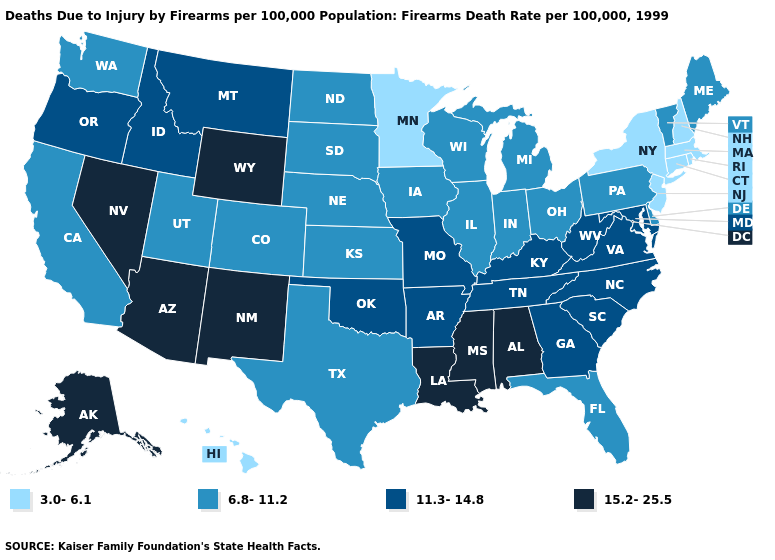What is the value of Delaware?
Answer briefly. 6.8-11.2. How many symbols are there in the legend?
Be succinct. 4. What is the value of Florida?
Answer briefly. 6.8-11.2. Does North Dakota have a higher value than Colorado?
Answer briefly. No. Does Nevada have the lowest value in the West?
Write a very short answer. No. Among the states that border Iowa , does Missouri have the highest value?
Keep it brief. Yes. What is the lowest value in the West?
Give a very brief answer. 3.0-6.1. Name the states that have a value in the range 15.2-25.5?
Write a very short answer. Alabama, Alaska, Arizona, Louisiana, Mississippi, Nevada, New Mexico, Wyoming. What is the lowest value in the USA?
Write a very short answer. 3.0-6.1. Name the states that have a value in the range 3.0-6.1?
Quick response, please. Connecticut, Hawaii, Massachusetts, Minnesota, New Hampshire, New Jersey, New York, Rhode Island. What is the lowest value in the USA?
Quick response, please. 3.0-6.1. Name the states that have a value in the range 6.8-11.2?
Concise answer only. California, Colorado, Delaware, Florida, Illinois, Indiana, Iowa, Kansas, Maine, Michigan, Nebraska, North Dakota, Ohio, Pennsylvania, South Dakota, Texas, Utah, Vermont, Washington, Wisconsin. Name the states that have a value in the range 3.0-6.1?
Give a very brief answer. Connecticut, Hawaii, Massachusetts, Minnesota, New Hampshire, New Jersey, New York, Rhode Island. Does Massachusetts have the lowest value in the USA?
Write a very short answer. Yes. What is the value of Vermont?
Give a very brief answer. 6.8-11.2. 